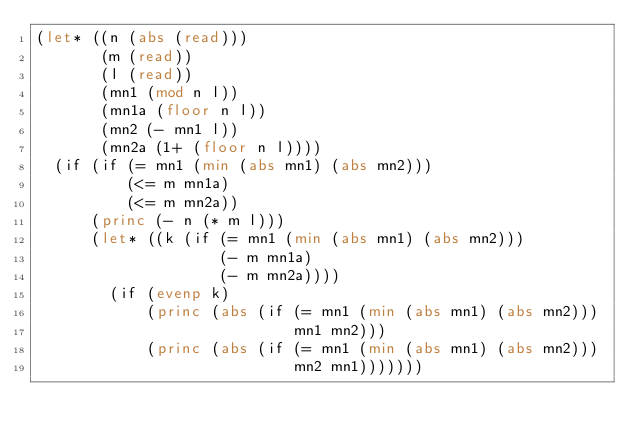<code> <loc_0><loc_0><loc_500><loc_500><_Lisp_>(let* ((n (abs (read)))
       (m (read))
       (l (read))
       (mn1 (mod n l))
       (mn1a (floor n l))
       (mn2 (- mn1 l))
       (mn2a (1+ (floor n l))))
  (if (if (= mn1 (min (abs mn1) (abs mn2)))
          (<= m mn1a)
          (<= m mn2a))
      (princ (- n (* m l)))
      (let* ((k (if (= mn1 (min (abs mn1) (abs mn2)))
                    (- m mn1a)
                    (- m mn2a))))
        (if (evenp k)
            (princ (abs (if (= mn1 (min (abs mn1) (abs mn2)))
                            mn1 mn2)))
            (princ (abs (if (= mn1 (min (abs mn1) (abs mn2)))
                            mn2 mn1)))))))</code> 